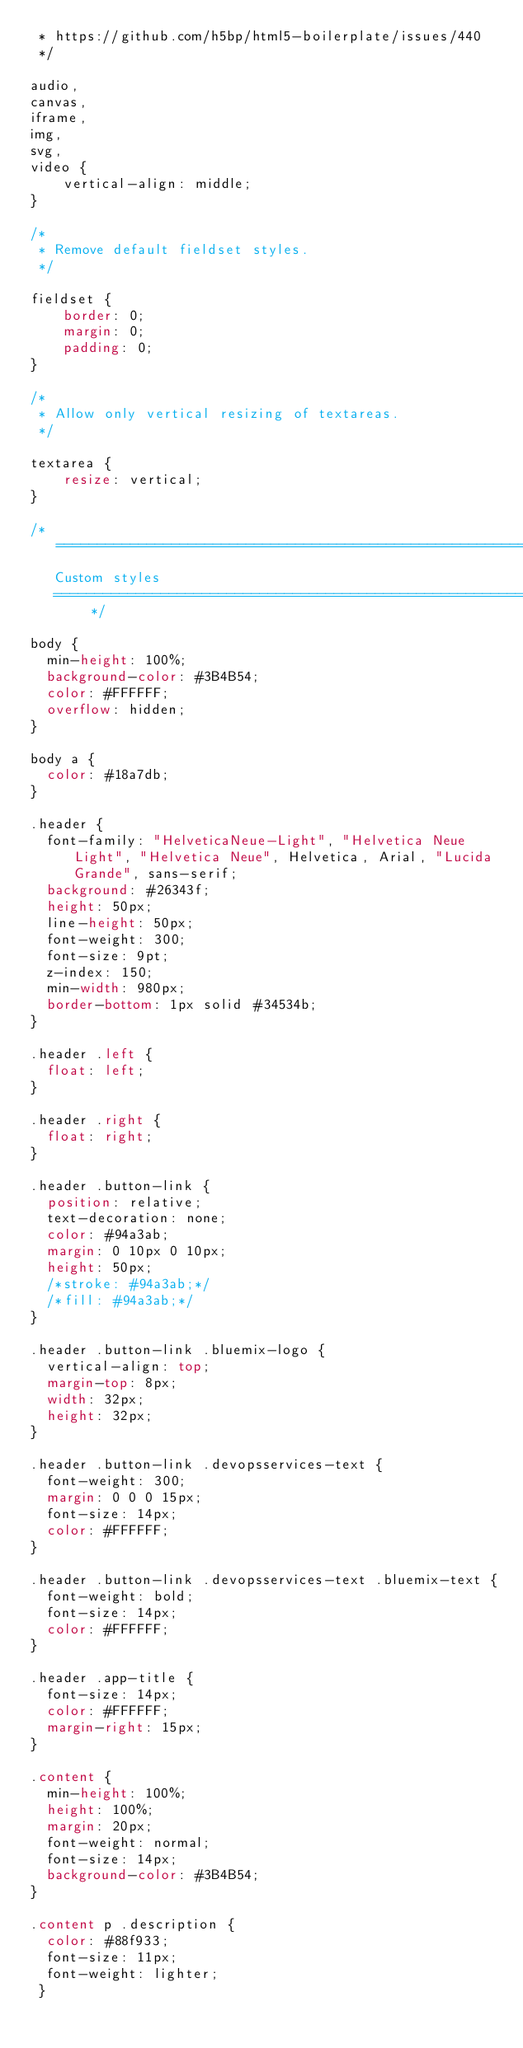<code> <loc_0><loc_0><loc_500><loc_500><_CSS_> * https://github.com/h5bp/html5-boilerplate/issues/440
 */

audio,
canvas,
iframe,
img,
svg,
video {
    vertical-align: middle;
}

/*
 * Remove default fieldset styles.
 */

fieldset {
    border: 0;
    margin: 0;
    padding: 0;
}

/*
 * Allow only vertical resizing of textareas.
 */

textarea {
    resize: vertical;
}

/* ==========================================================================
   Custom styles
   ========================================================================== */

body {
  min-height: 100%;
  background-color: #3B4B54;
  color: #FFFFFF;
  overflow: hidden;
}

body a {
  color: #18a7db;
}

.header {
  font-family: "HelveticaNeue-Light", "Helvetica Neue Light", "Helvetica Neue", Helvetica, Arial, "Lucida Grande", sans-serif;
  background: #26343f;
  height: 50px;
  line-height: 50px;
  font-weight: 300;
  font-size: 9pt;
  z-index: 150;
  min-width: 980px;
  border-bottom: 1px solid #34534b;
}

.header .left {
  float: left;
}

.header .right {
  float: right;
}

.header .button-link {
  position: relative;
  text-decoration: none;
  color: #94a3ab;
  margin: 0 10px 0 10px;
  height: 50px;
  /*stroke: #94a3ab;*/
  /*fill: #94a3ab;*/
}

.header .button-link .bluemix-logo {
  vertical-align: top;
  margin-top: 8px;
  width: 32px;
  height: 32px;
}

.header .button-link .devopsservices-text {
  font-weight: 300;
  margin: 0 0 0 15px;
  font-size: 14px;
  color: #FFFFFF;
}

.header .button-link .devopsservices-text .bluemix-text {
  font-weight: bold;
  font-size: 14px;
  color: #FFFFFF;
}

.header .app-title {
  font-size: 14px;
  color: #FFFFFF;
  margin-right: 15px;
}

.content {
  min-height: 100%;
  height: 100%;
  margin: 20px;
  font-weight: normal;
  font-size: 14px;
  background-color: #3B4B54;
}

.content p .description {
  color: #88f933;
  font-size: 11px;
  font-weight: lighter;
 }
</code> 